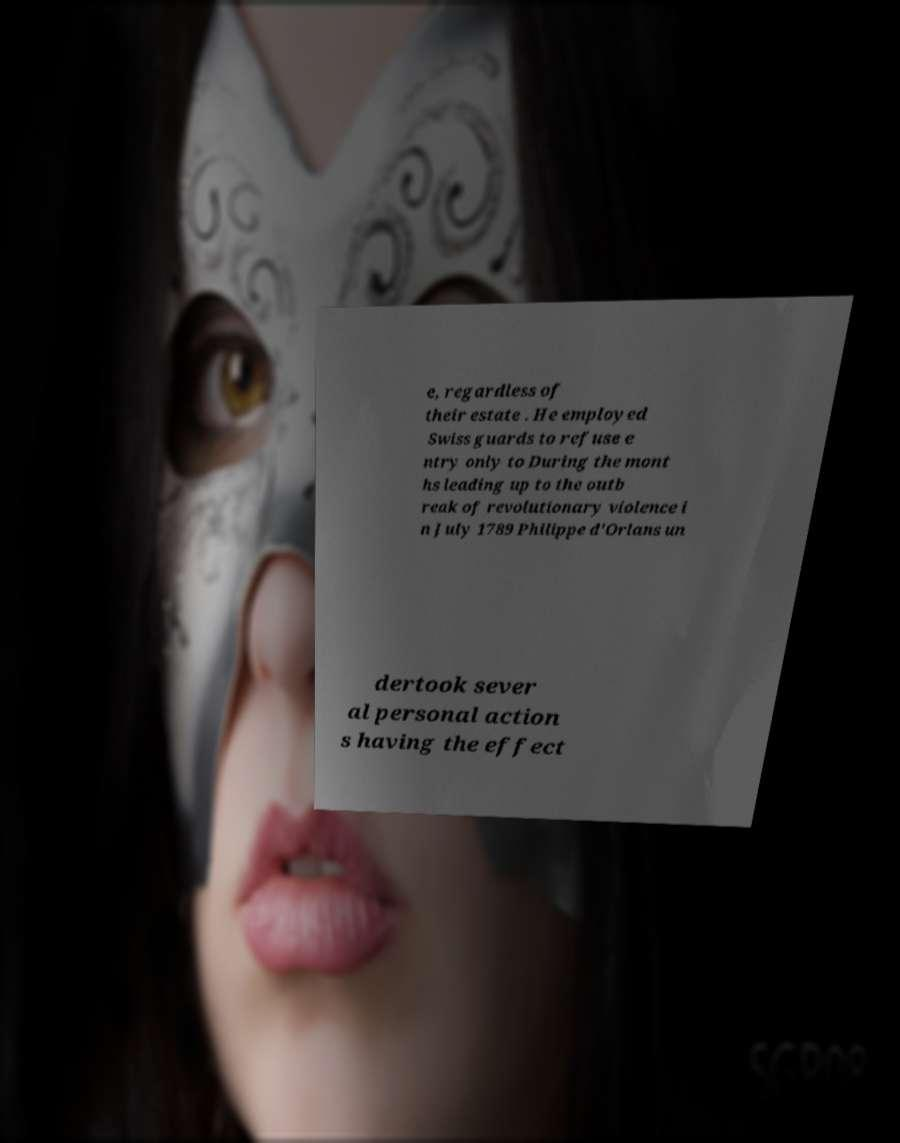What messages or text are displayed in this image? I need them in a readable, typed format. e, regardless of their estate . He employed Swiss guards to refuse e ntry only to During the mont hs leading up to the outb reak of revolutionary violence i n July 1789 Philippe d'Orlans un dertook sever al personal action s having the effect 